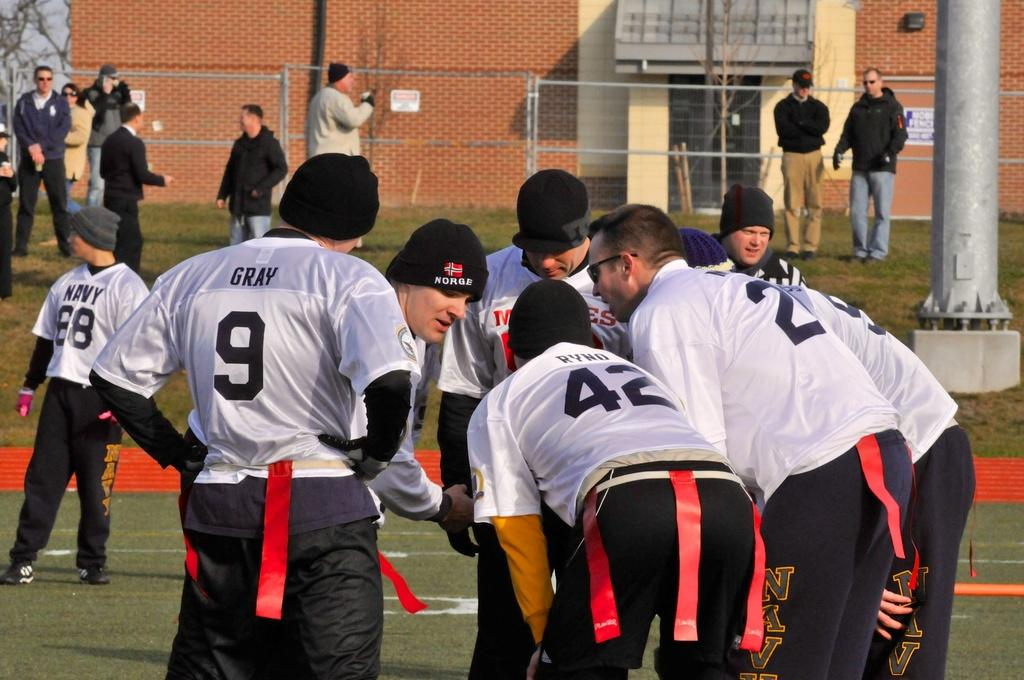<image>
Offer a succinct explanation of the picture presented. Team member in a white jersey with Gray on the back in black. 